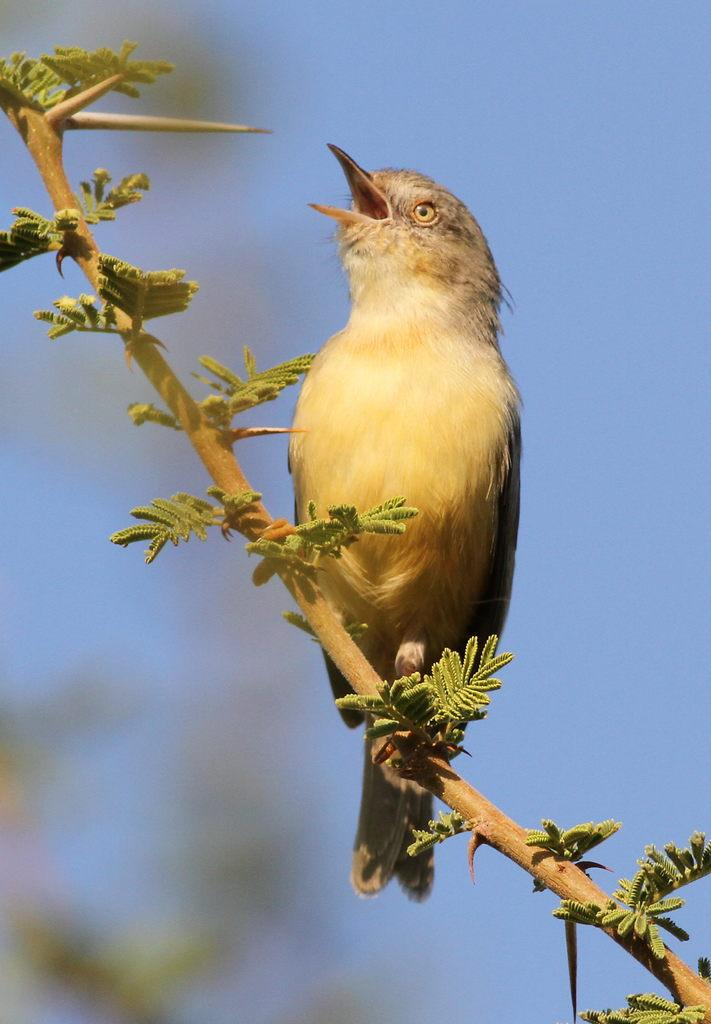What type of animal can be seen in the image? There is a bird in the image. What colors are present on the bird? The bird has cream and black coloring. Where is the bird located in the image? The bird is on a branch. What type of vegetation is visible in the image? There are green leaves visible in the image. What color is the sky in the image? The sky is blue in the image. What is the bird's opinion on the current political climate in the image? The image does not provide any information about the bird's opinion on the current political climate, as it is focused on the bird's appearance and location. 